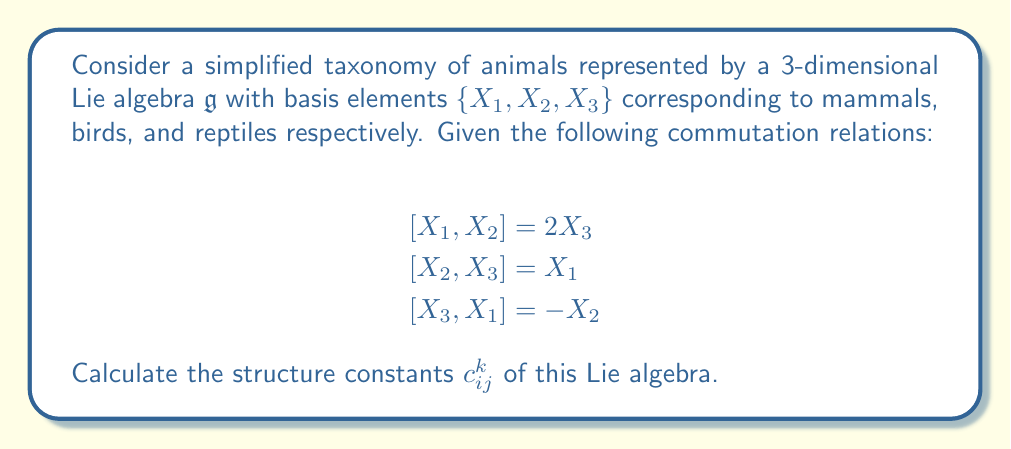Provide a solution to this math problem. To calculate the structure constants of a Lie algebra, we need to express the commutation relations in terms of the structure constants using the general formula:

$$[X_i, X_j] = \sum_{k=1}^3 c_{ij}^k X_k$$

Let's analyze each commutation relation:

1) $[X_1, X_2] = 2X_3$
   This implies $c_{12}^3 = 2$, and $c_{12}^1 = c_{12}^2 = 0$

2) $[X_2, X_3] = X_1$
   This implies $c_{23}^1 = 1$, and $c_{23}^2 = c_{23}^3 = 0$

3) $[X_3, X_1] = -X_2$
   This implies $c_{31}^2 = -1$, and $c_{31}^1 = c_{31}^3 = 0$

Note that the structure constants are antisymmetric in the lower indices, meaning:
$$c_{ij}^k = -c_{ji}^k$$

Therefore, we can deduce:
$c_{21}^3 = -2$
$c_{32}^1 = -1$
$c_{13}^2 = 1$

All other structure constants not mentioned are zero.

We can summarize the non-zero structure constants as:

$$c_{12}^3 = 2, \quad c_{23}^1 = 1, \quad c_{31}^2 = -1$$
$$c_{21}^3 = -2, \quad c_{32}^1 = -1, \quad c_{13}^2 = 1$$
Answer: The non-zero structure constants of the Lie algebra are:
$$c_{12}^3 = 2, \quad c_{23}^1 = 1, \quad c_{31}^2 = -1$$
$$c_{21}^3 = -2, \quad c_{32}^1 = -1, \quad c_{13}^2 = 1$$
All other structure constants are zero. 